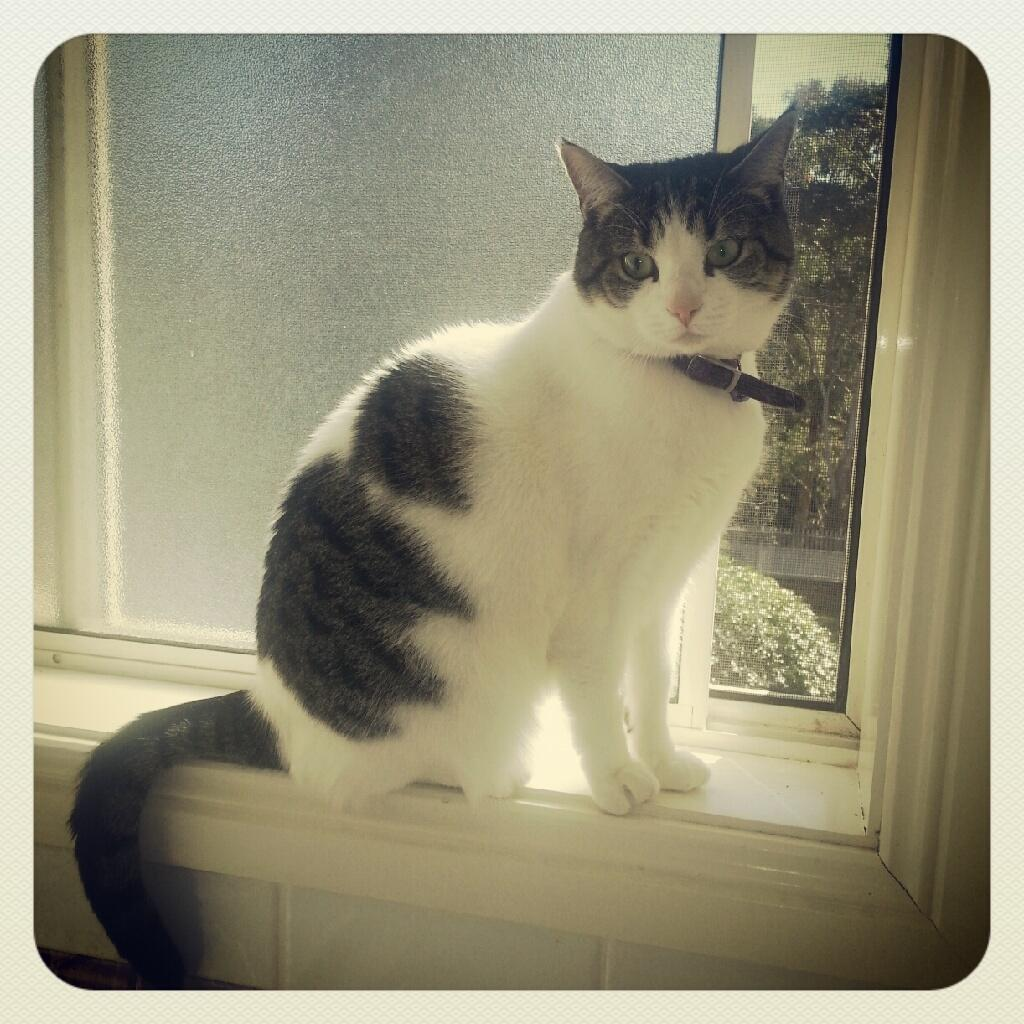What type of animal is in the image? There is a cat in the image. Where is the cat located in relation to the window? The cat is near a window. What can be seen outside the window? Plants and trees are visible outside the window. What is the cat wearing around its neck? The cat has a belt on its neck. What type of marble is visible on the floor in the image? There is no marble visible on the floor in the image; it is not mentioned in the provided facts. 